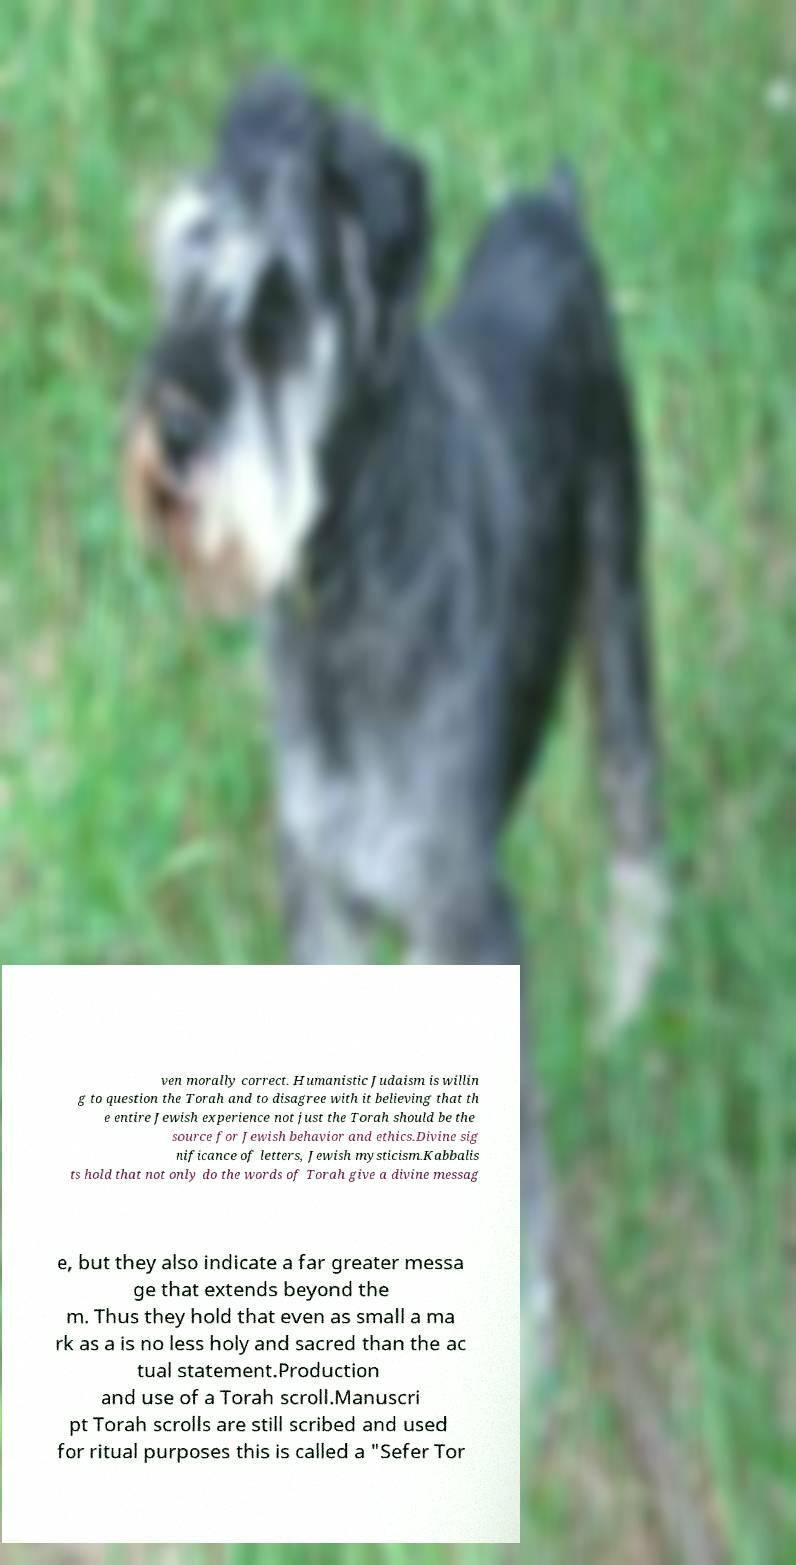I need the written content from this picture converted into text. Can you do that? ven morally correct. Humanistic Judaism is willin g to question the Torah and to disagree with it believing that th e entire Jewish experience not just the Torah should be the source for Jewish behavior and ethics.Divine sig nificance of letters, Jewish mysticism.Kabbalis ts hold that not only do the words of Torah give a divine messag e, but they also indicate a far greater messa ge that extends beyond the m. Thus they hold that even as small a ma rk as a is no less holy and sacred than the ac tual statement.Production and use of a Torah scroll.Manuscri pt Torah scrolls are still scribed and used for ritual purposes this is called a "Sefer Tor 